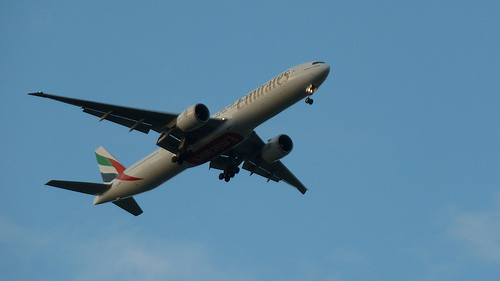How fast might the airplane be traveling? Commercial airplanes typically cruise at speeds around 500 to 600 miles per hour. This one likely falls within that range. 